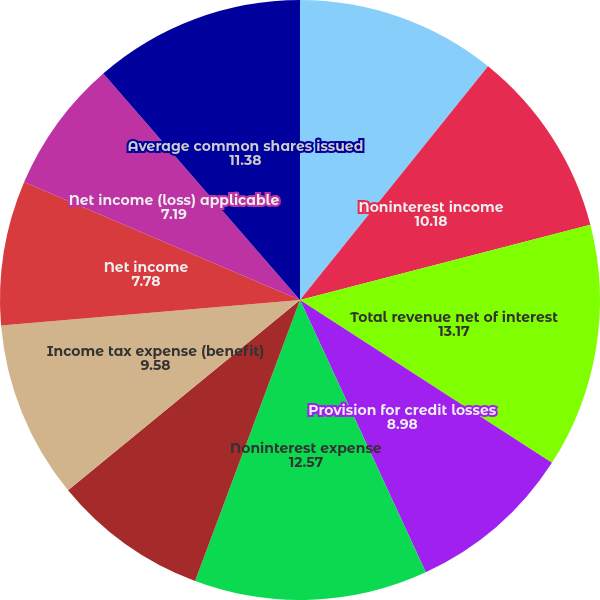<chart> <loc_0><loc_0><loc_500><loc_500><pie_chart><fcel>Net interest income<fcel>Noninterest income<fcel>Total revenue net of interest<fcel>Provision for credit losses<fcel>Noninterest expense<fcel>Income (loss) before income<fcel>Income tax expense (benefit)<fcel>Net income<fcel>Net income (loss) applicable<fcel>Average common shares issued<nl><fcel>10.78%<fcel>10.18%<fcel>13.17%<fcel>8.98%<fcel>12.57%<fcel>8.38%<fcel>9.58%<fcel>7.78%<fcel>7.19%<fcel>11.38%<nl></chart> 